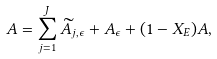<formula> <loc_0><loc_0><loc_500><loc_500>A = \sum _ { j = 1 } ^ { J } \widetilde { A } _ { j , \epsilon } + A _ { \epsilon } + ( 1 - X _ { E } ) A ,</formula> 